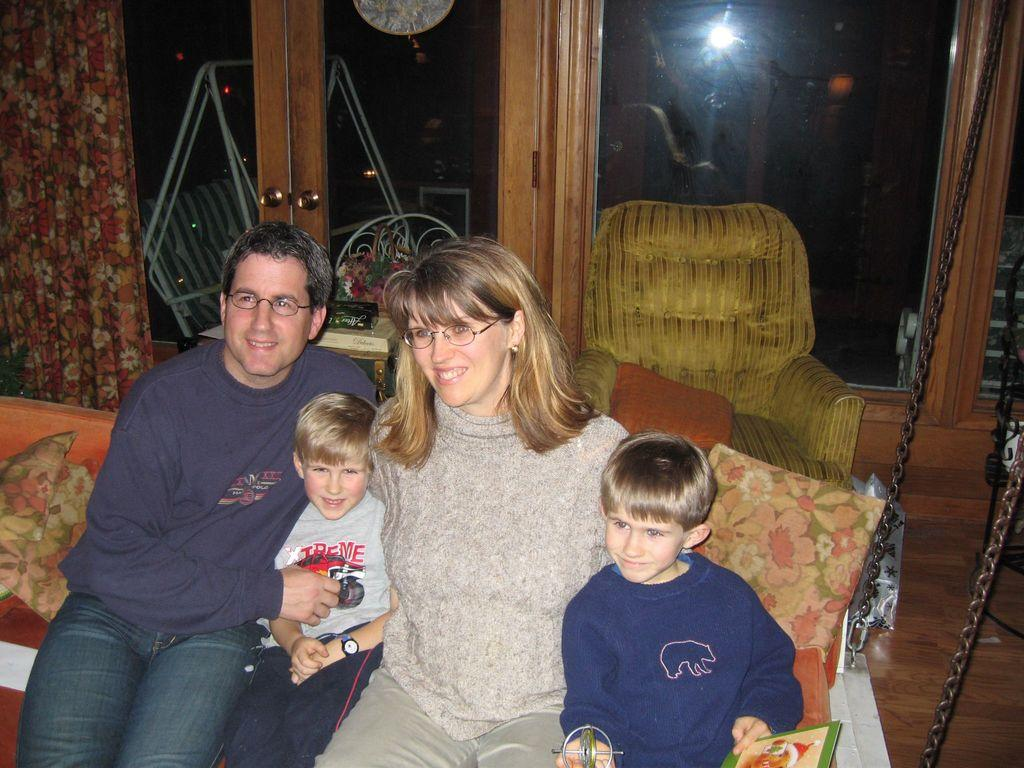How many people are present in the image? There are four people in the image. What expressions do the people have? The people are smiling in the image. What can be seen in the background of the image? There are pillows, chairs, a curtain, and cupboards in the background of the image. What country is the image taken in? The provided facts do not mention the country in which the image was taken, so it cannot be determined from the information given. 